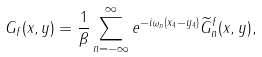<formula> <loc_0><loc_0><loc_500><loc_500>G _ { f } ( x , y ) = \frac { 1 } { \beta } \sum _ { n = - \infty } ^ { \infty } e ^ { - i \omega _ { n } ( x _ { 4 } - y _ { 4 } ) } \widetilde { G } _ { n } ^ { f } ( x , y ) ,</formula> 